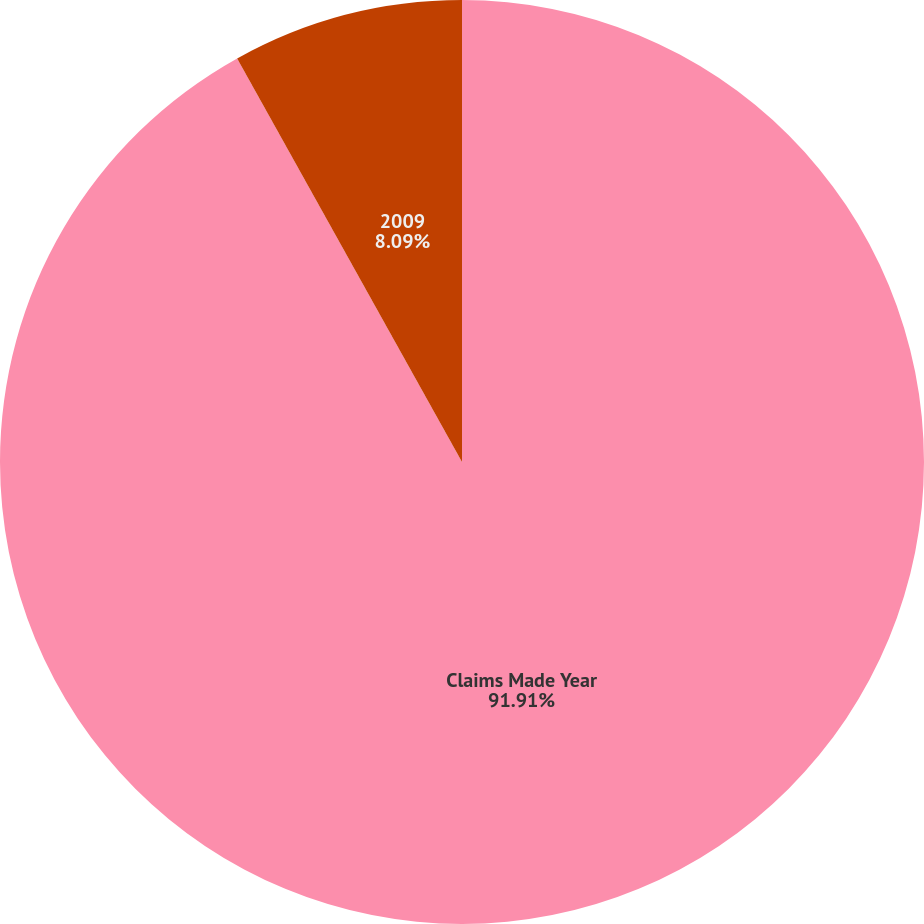<chart> <loc_0><loc_0><loc_500><loc_500><pie_chart><fcel>Claims Made Year<fcel>2009<nl><fcel>91.91%<fcel>8.09%<nl></chart> 